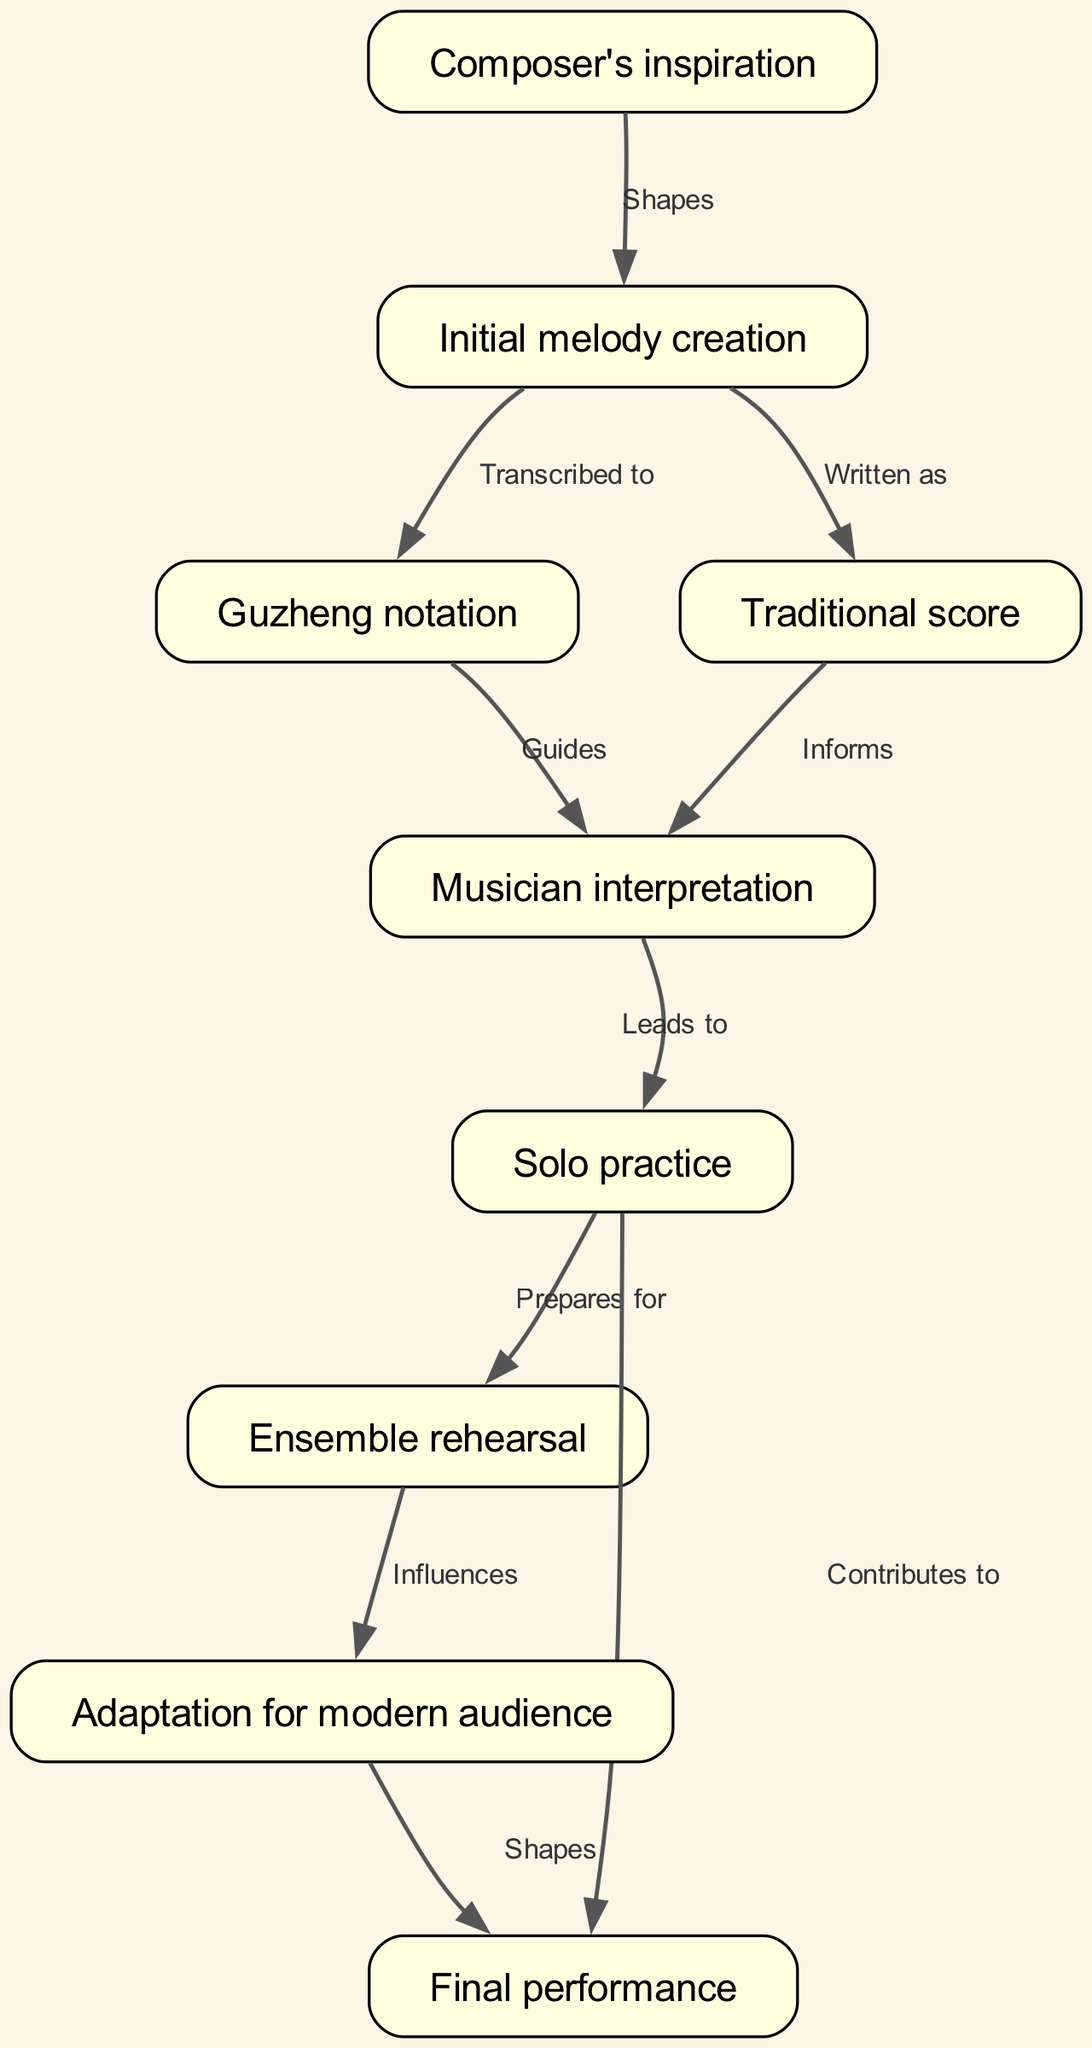What is the first stage of the journey? The diagram starts with the node labeled "Composer's inspiration," indicating that this is the initial stage of the melody's journey.
Answer: Composer's inspiration How many nodes are present in the diagram? The diagram lists a total of nine distinct nodes, each representing a significant step in the process of a guzheng melody's journey.
Answer: 9 Which nodes influence the "Musician interpretation"? The nodes "Guzheng notation" and "Traditional score" guide the musician's interpretation, as indicated by the edges pointing towards this node.
Answer: Guzheng notation, Traditional score What leads to solo practice? The diagram shows that the "Musician interpretation" is the direct predecessor that leads to "Solo practice," indicating that an understanding of the piece is necessary before practicing it solo.
Answer: Musician interpretation How does "Ensemble rehearsal" affect the final performance? The edge from "Ensemble rehearsal" to "Final performance" indicates a direct influence, meaning that what happens during rehearsals shapes how the final performance is executed.
Answer: Shapes What does the adaptation for a modern audience influence? The diagram specifies that "Adaptation for modern audience" shapes the "Final performance," meaning that changes made to make the melody more relatable to contemporary audiences directly affect the performance.
Answer: Final performance Which step occurs after "Solo practice"? According to the diagram, the step that follows "Solo practice" is "Ensemble rehearsal," indicating a progression from individual preparation to collaborative practice.
Answer: Ensemble rehearsal How is the initial melody transcribed? The diagram details that the initial melody is transcribed to "Guzheng notation," demonstrating the transition from composition to notation.
Answer: Guzheng notation Which node directly influences "Final performance" besides "Adaptation for modern audience"? The edge from "Solo practice" also contributes to the "Final performance," meaning both solo practice and adaptation play significant roles in shaping the final presentation.
Answer: Solo practice 